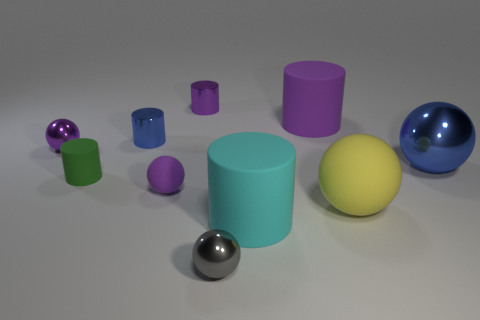Subtract all purple cylinders. How many were subtracted if there are1purple cylinders left? 1 Subtract all blue cylinders. How many cylinders are left? 4 Subtract all small purple metal cylinders. How many cylinders are left? 4 Subtract all cyan balls. Subtract all blue cylinders. How many balls are left? 5 Add 3 purple shiny spheres. How many purple shiny spheres are left? 4 Add 6 gray objects. How many gray objects exist? 7 Subtract 0 yellow cylinders. How many objects are left? 10 Subtract all tiny gray things. Subtract all matte cylinders. How many objects are left? 6 